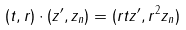<formula> <loc_0><loc_0><loc_500><loc_500>( t , r ) \cdot ( z ^ { \prime } , z _ { n } ) = ( r t z ^ { \prime } , r ^ { 2 } z _ { n } )</formula> 